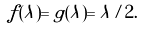Convert formula to latex. <formula><loc_0><loc_0><loc_500><loc_500>f ( \lambda ) = g ( \lambda ) = \lambda / 2 .</formula> 